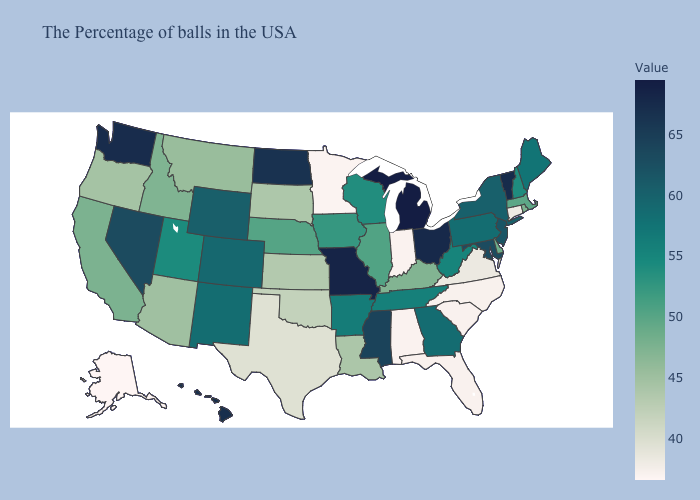Does Alaska have the lowest value in the USA?
Keep it brief. Yes. Among the states that border Texas , does New Mexico have the highest value?
Answer briefly. Yes. Does Alaska have the lowest value in the USA?
Give a very brief answer. Yes. Does the map have missing data?
Quick response, please. No. Which states have the highest value in the USA?
Short answer required. Michigan. 